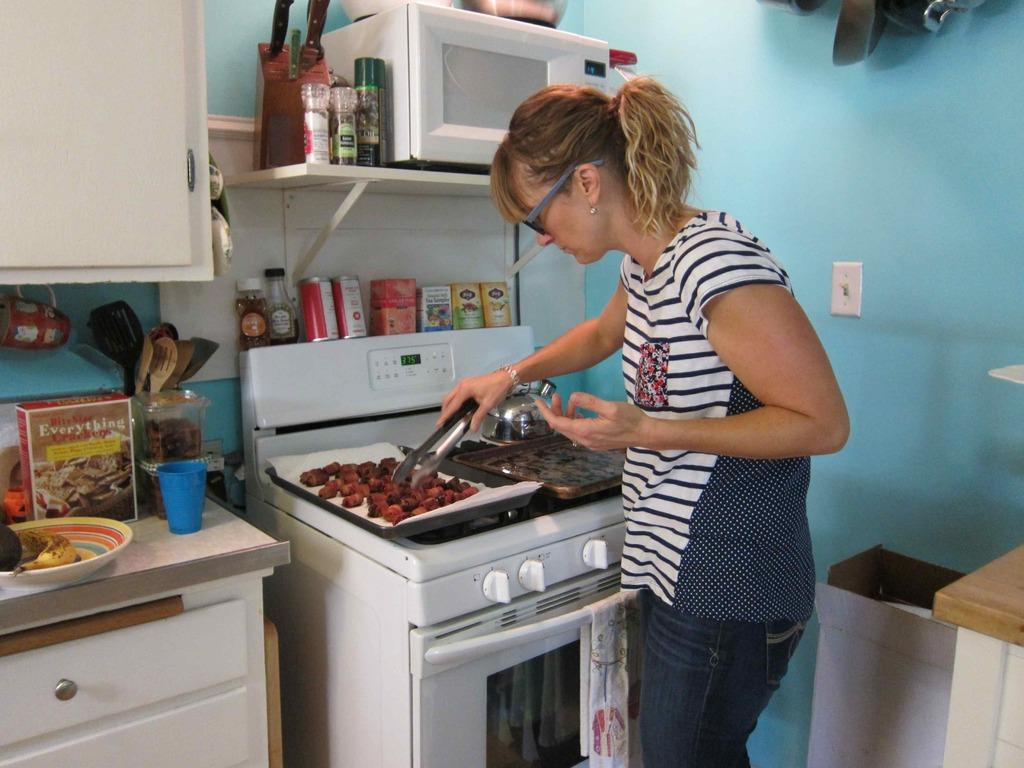Provide a one-sentence caption for the provided image. A woman holding tongs over a baking sheet filled with food and a box of "Bite size Everything Crackers" on the counter beside her. 